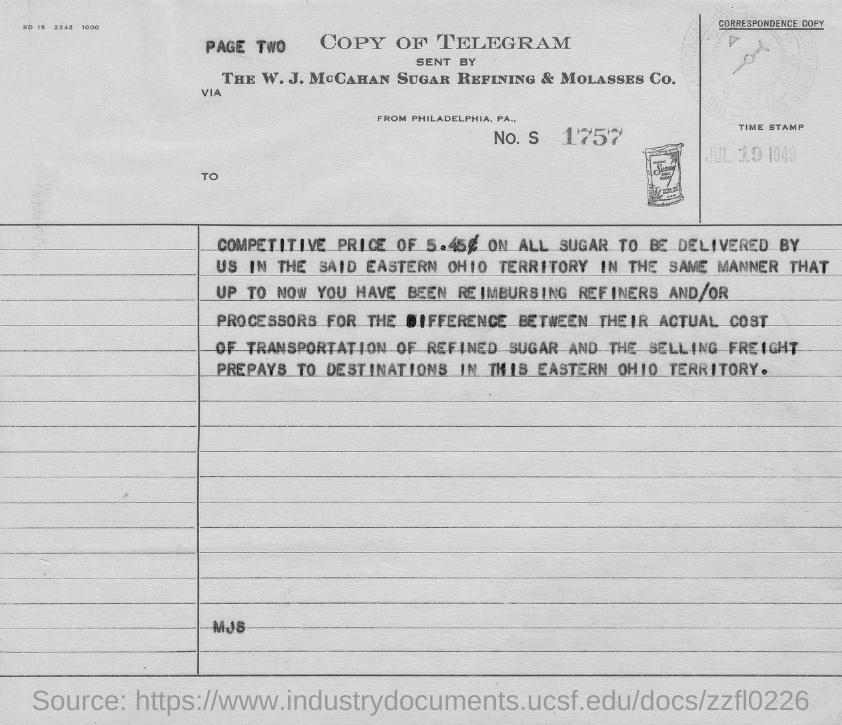Outline some significant characteristics in this image. The document in question is a copy of a telegram. On July 19, 1943, the date was stamped. The Telegram originated from the city of Philadelphia, Pennsylvania. 